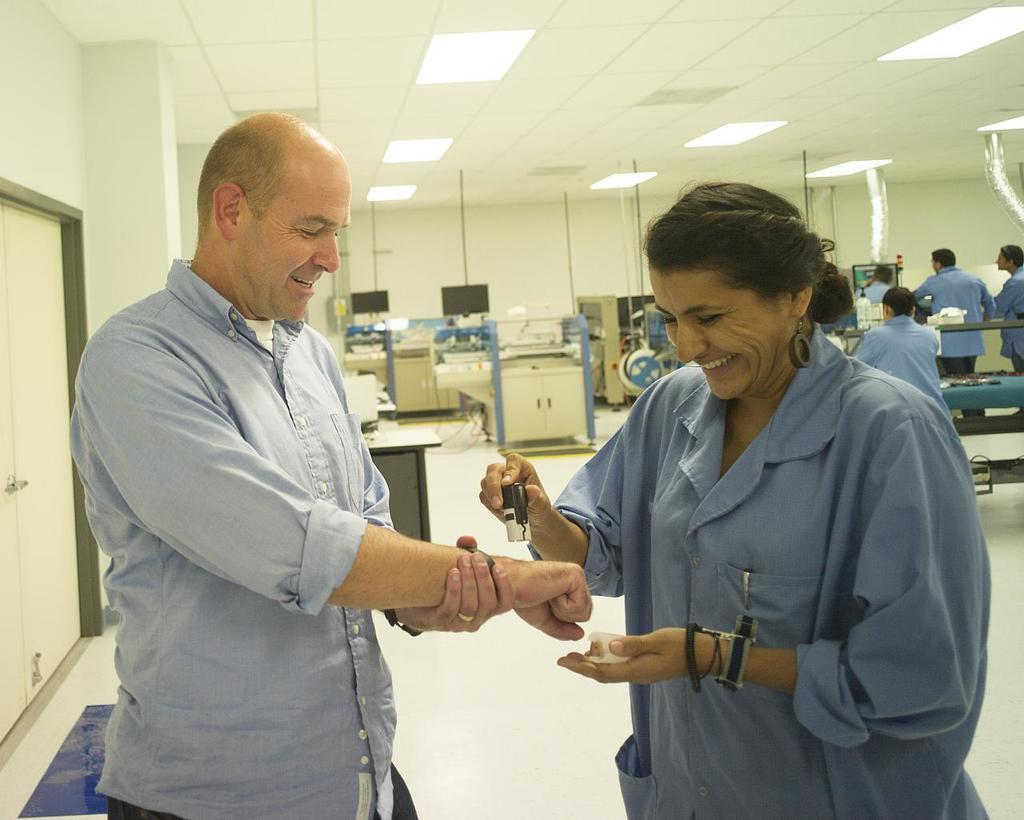Who or what is present in the image? There are people in the image. What is located near the entrance in the image? There is a doormat in the image. What type of furniture can be seen in the image? There are tables in the image. What provides illumination in the image? There are lights in the image. What type of equipment is present in the image? There are electrical equipments in the image. What type of berry is being used as a decoration on the doormat in the image? There is no berry present on the doormat in the image; it is a doormat without any berries. 